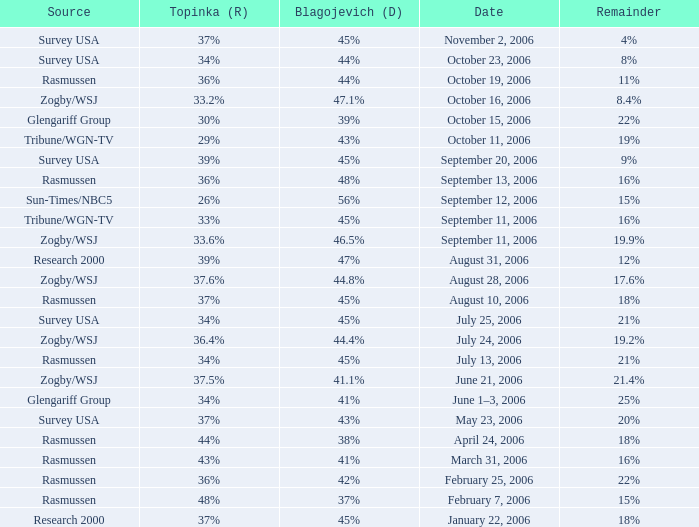Which Date has a Remainder of 20%? May 23, 2006. 